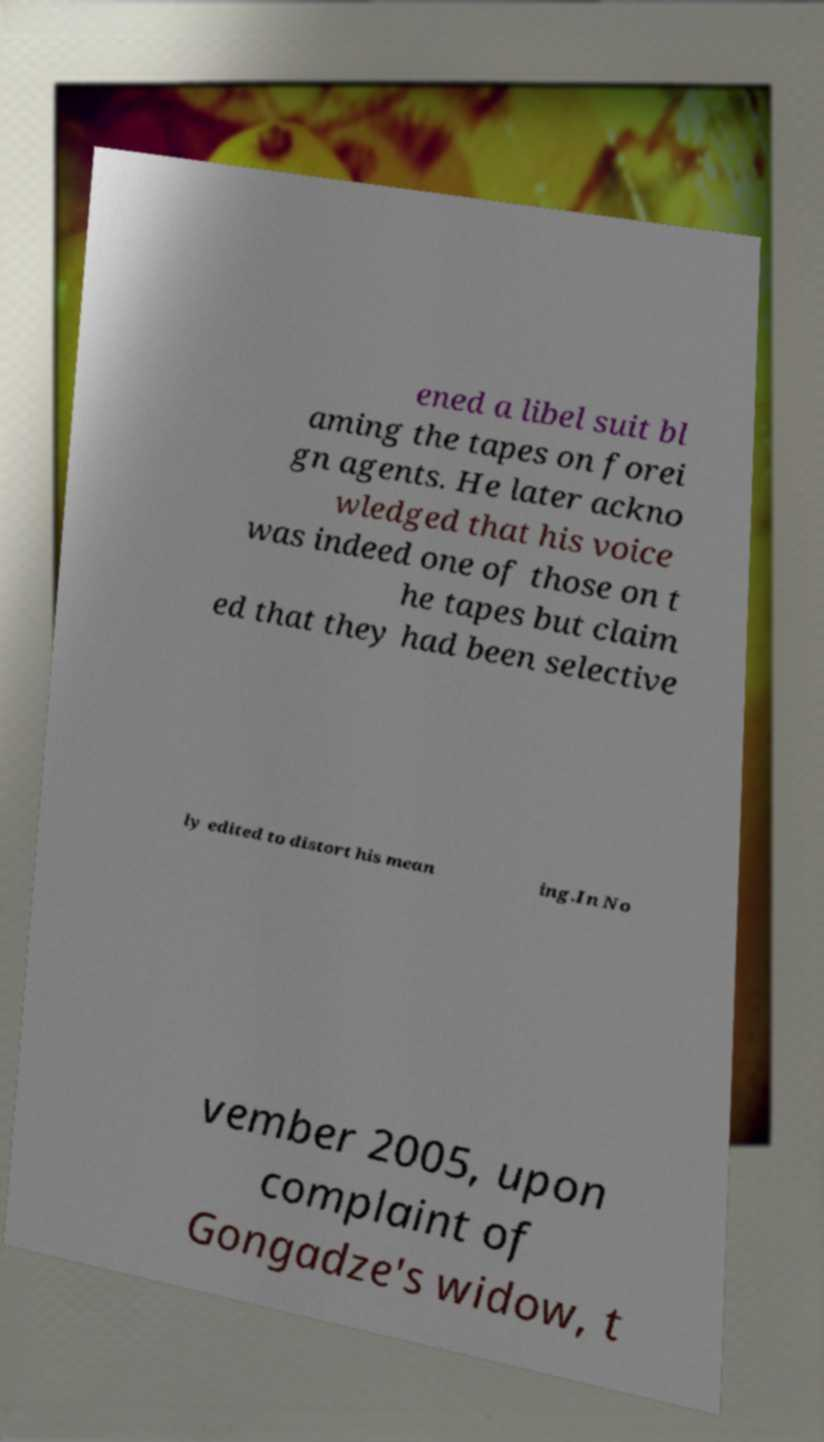Could you extract and type out the text from this image? ened a libel suit bl aming the tapes on forei gn agents. He later ackno wledged that his voice was indeed one of those on t he tapes but claim ed that they had been selective ly edited to distort his mean ing.In No vember 2005, upon complaint of Gongadze's widow, t 